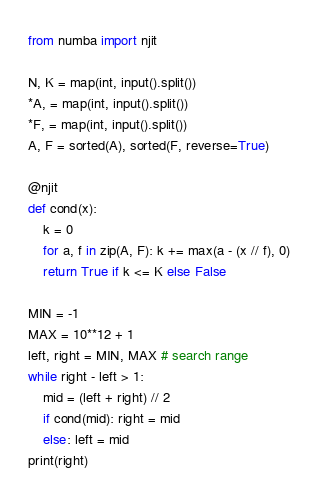<code> <loc_0><loc_0><loc_500><loc_500><_Python_>from numba import njit

N, K = map(int, input().split())
*A, = map(int, input().split())
*F, = map(int, input().split())
A, F = sorted(A), sorted(F, reverse=True)

@njit
def cond(x):
    k = 0
    for a, f in zip(A, F): k += max(a - (x // f), 0)
    return True if k <= K else False 

MIN = -1
MAX = 10**12 + 1
left, right = MIN, MAX # search range
while right - left > 1:
    mid = (left + right) // 2
    if cond(mid): right = mid
    else: left = mid
print(right)</code> 